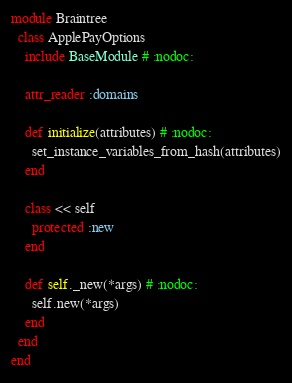<code> <loc_0><loc_0><loc_500><loc_500><_Ruby_>module Braintree
  class ApplePayOptions
    include BaseModule # :nodoc:

    attr_reader :domains

    def initialize(attributes) # :nodoc:
      set_instance_variables_from_hash(attributes)
    end

    class << self
      protected :new
    end

    def self._new(*args) # :nodoc:
      self.new(*args)
    end
  end
end
</code> 